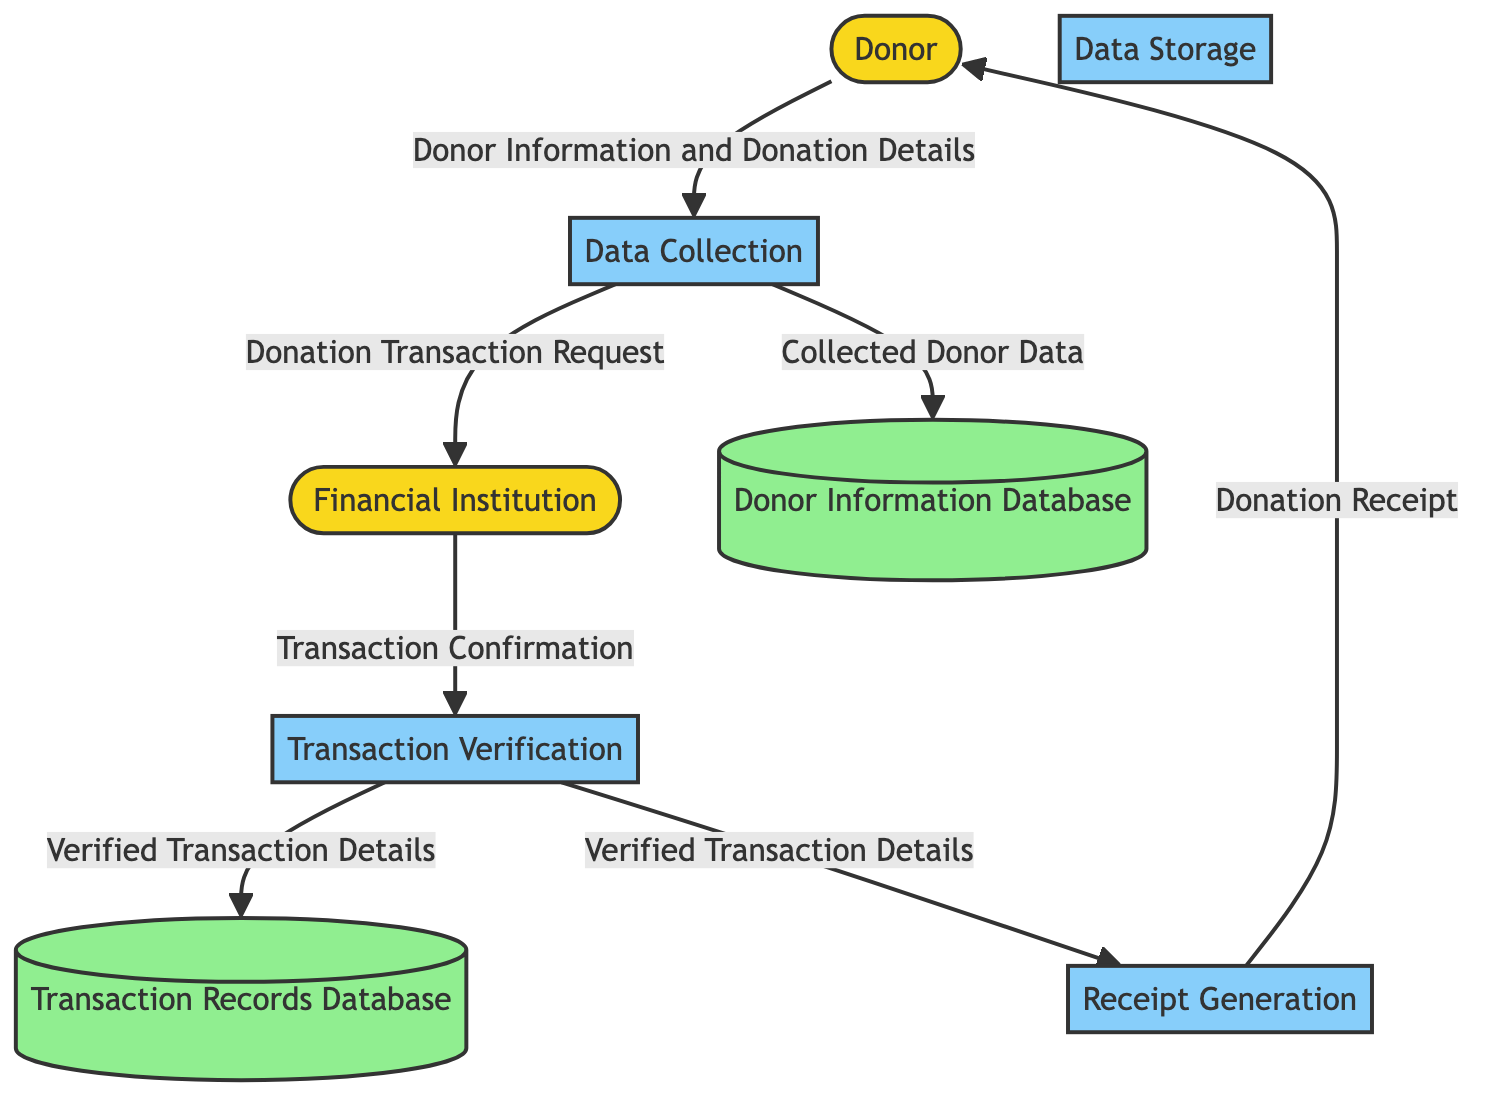What is the main purpose of the Data Collection process? The Data Collection process is responsible for gathering donor information and donation details from various sources, such as web forms and emails. This is necessary to start the donation management flow.
Answer: Gathering donor information and donation details How many data stores are present in the diagram? The diagram includes two data stores: the Donor Information Database and the Transaction Records Database. These stores organize and secure the data related to donors and transactions.
Answer: 2 What flows from the Data Collection process to the Financial Institution? The flow from the Data Collection process to the Financial Institution consists of the Donation Transaction Request, which initiates the transaction verification process with the bank or financial service provider.
Answer: Donation Transaction Request Which process confirms the donation transaction details? The Transaction Verification process handles the confirmation of donation transaction details, following the transaction request sent to the Financial Institution.
Answer: Transaction Verification What is the final output sent to the Donor? The final output sent to the Donor is the Donation Receipt, which serves as proof of the donation made by the donor and is generated as per the verified transaction details.
Answer: Donation Receipt How are verified transaction details utilized after Transaction Verification? After the Transaction Verification process, verified transaction details are utilized for two purposes: they are stored in the Transaction Records Database and used to generate the Receipt. This ensures both record-keeping and acknowledgment of the donation to the donor.
Answer: Stored and used for Receipt Generation 